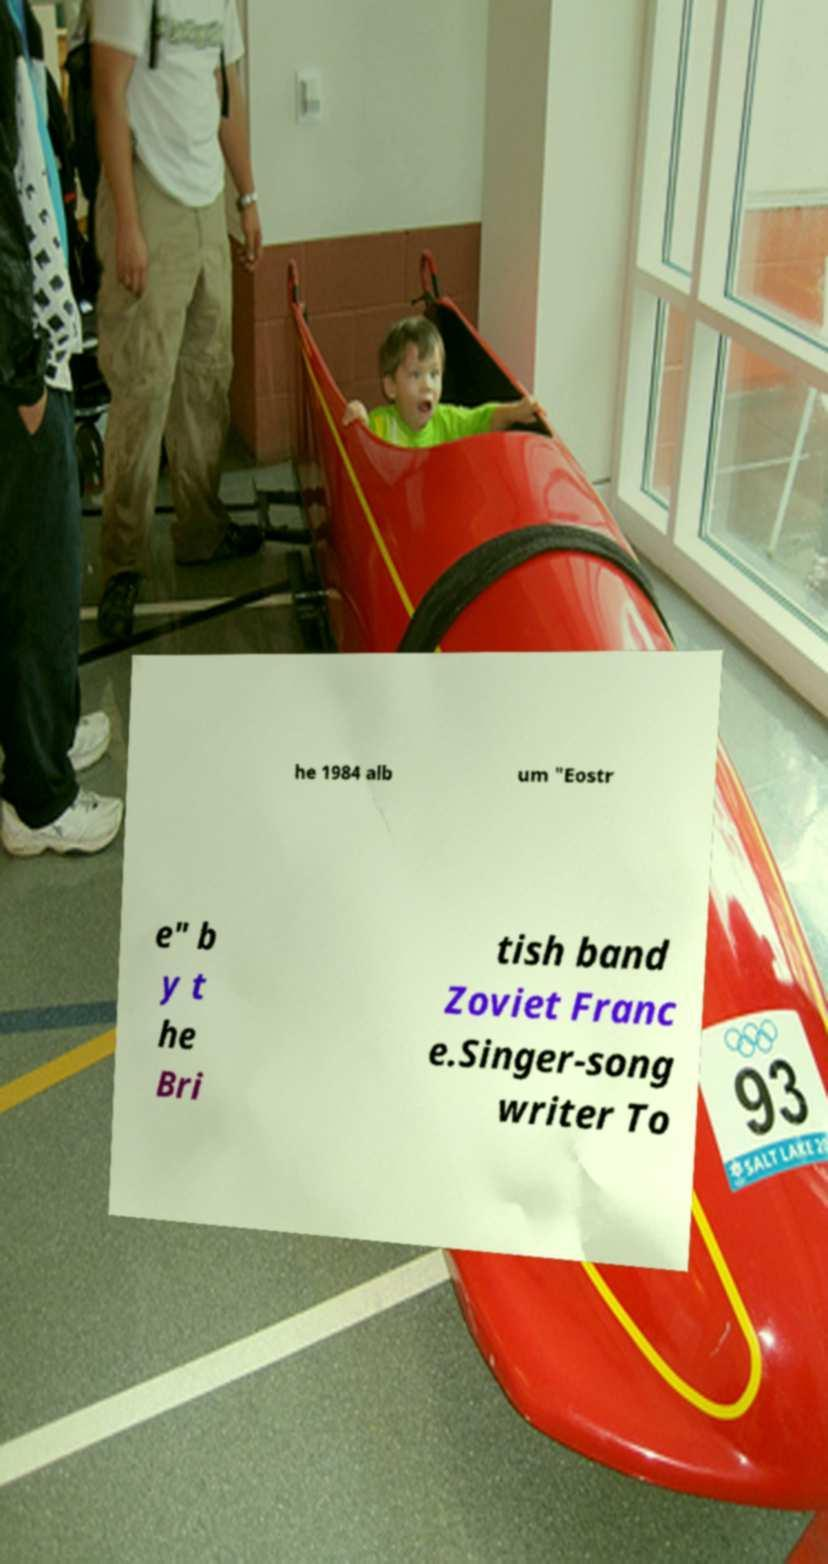Could you extract and type out the text from this image? he 1984 alb um "Eostr e" b y t he Bri tish band Zoviet Franc e.Singer-song writer To 